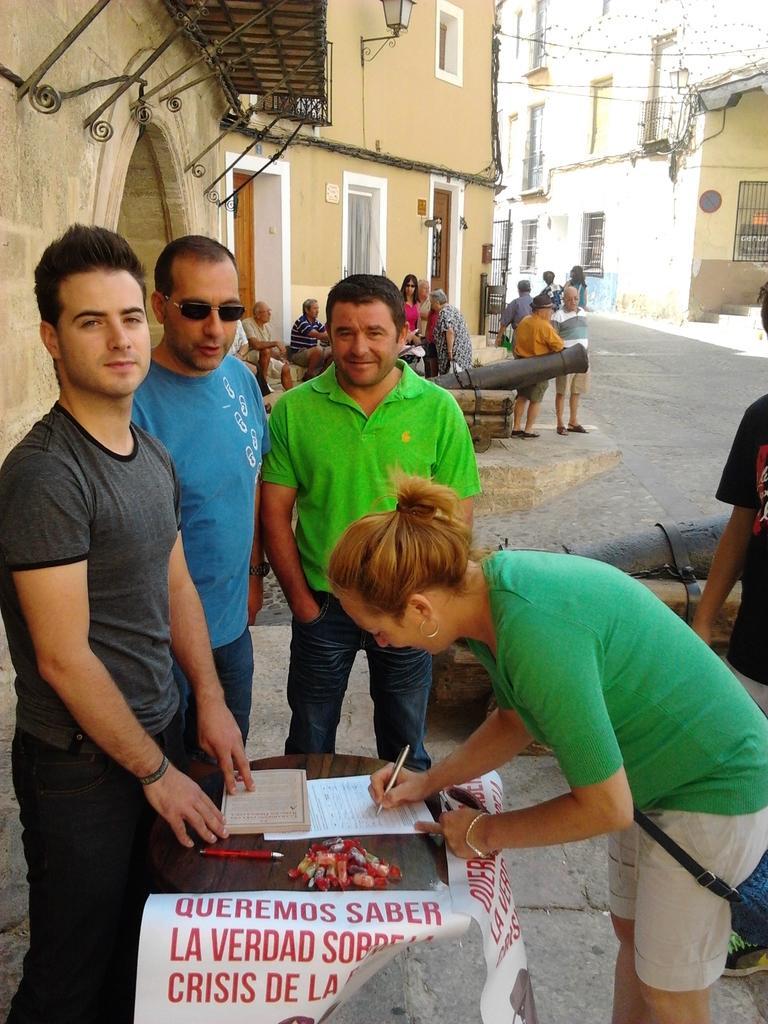Describe this image in one or two sentences. On the background of the picture we can see a building. This is a road. Here we can see few persons standing and sitting. Infront of the picture we can see a table on which there is a book and a paper and one woman is writing something on the paper. Here we can see three men standing and looking at the camera. 